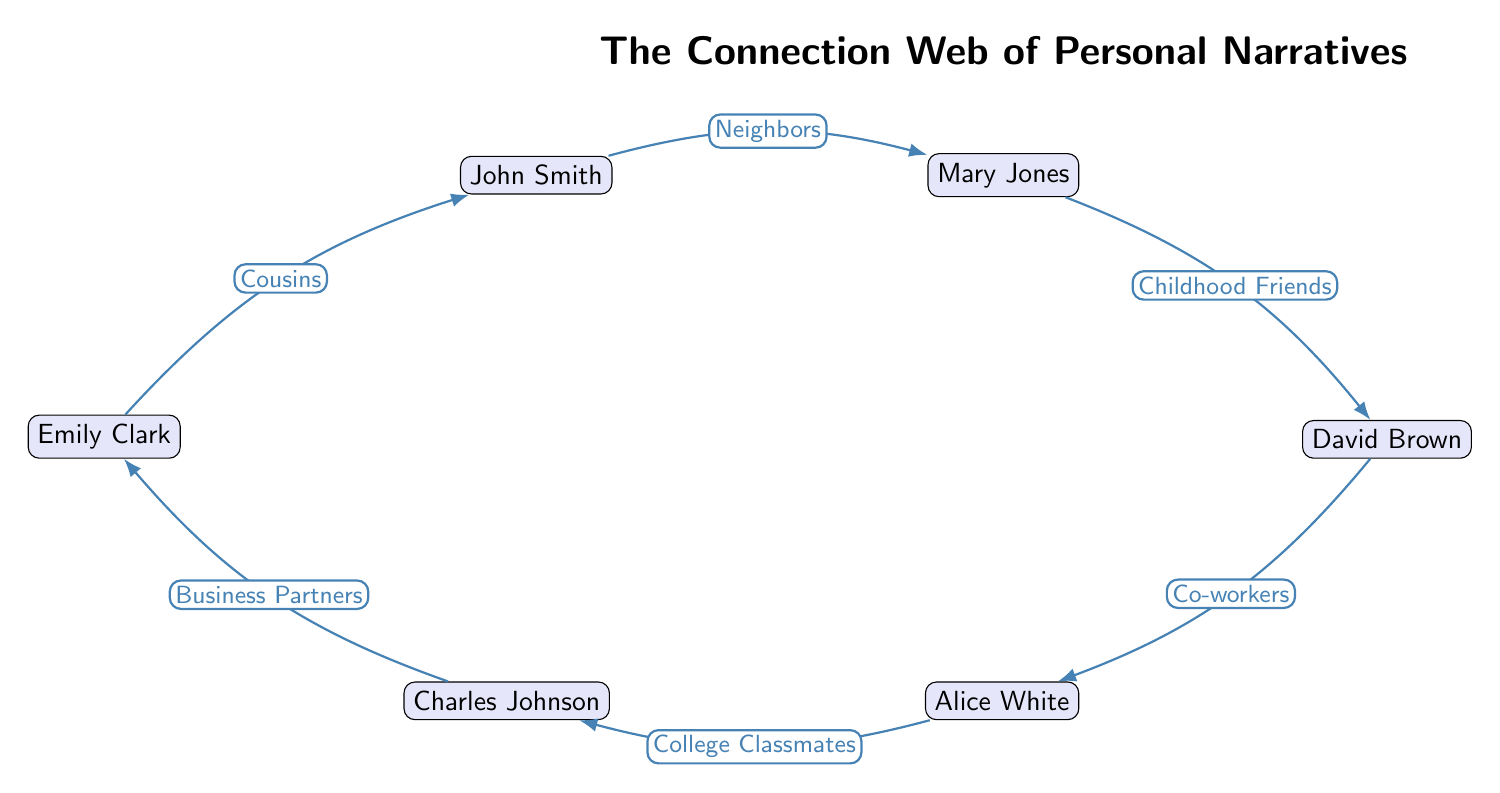What is the total number of individuals represented in the diagram? The diagram contains six individuals: John Smith, Mary Jones, David Brown, Alice White, Charles Johnson, and Emily Clark. Therefore, we count them all to arrive at the total.
Answer: 6 Who are the childhood friends according to the diagram? The edge labeled "Childhood Friends" connects Mary Jones and David Brown. Thus, these two individuals have this relationship in the diagram.
Answer: Mary Jones and David Brown What type of relationship exists between John Smith and Emily Clark? The relationship between John Smith and Emily Clark is labeled "Cousins" in the diagram, indicating their familial connection.
Answer: Cousins How many total connections (edges) are represented in the diagram? The diagram shows five edges that connect the individuals. We can count these edges to determine the total number of connections.
Answer: 5 Who is both a co-worker of David Brown and a college classmate of Charles Johnson? The edge labeled "Co-workers" connects David Brown and Alice White. Alice White is also connected to Charles Johnson by the edge labeled "College Classmates." Therefore, Alice White fits both criteria.
Answer: Alice White Which individuals have a relationship indicating business partnership? The diagram outlines that Charles Johnson and Emily Clark have a relationship labeled "Business Partners." This indicates their professional connection as specified in the edge.
Answer: Charles Johnson and Emily Clark What are the two connections that involve Mary Jones? Analyzing the diagram, Mary Jones is connected to John Smith with a "Neighbors" relationship and to David Brown with a "Childhood Friends" relationship. Thus, these are the two connections involving Mary Jones.
Answer: John Smith and David Brown Which individual is directly connected to both John Smith and David Brown? The individual that is directly connected to John Smith (via "Cousins") and to David Brown (via "Childhood Friends") is Mary Jones. This shows her central position in relation to these two individuals.
Answer: Mary Jones Which pair of individuals are connected as business partners? The individuals connected as business partners in the diagram are Charles Johnson and Emily Clark, represented by the edge labeled "Business Partners."
Answer: Charles Johnson and Emily Clark 